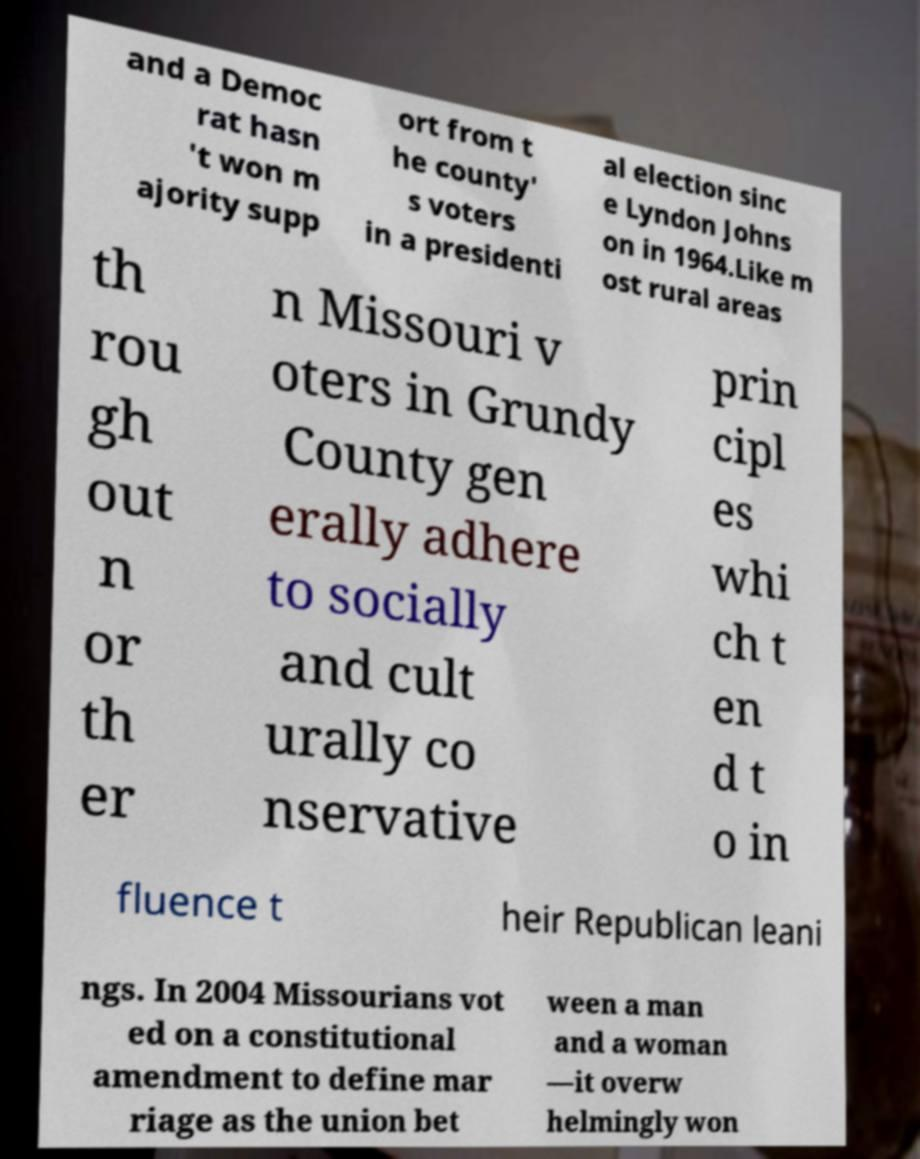Could you assist in decoding the text presented in this image and type it out clearly? and a Democ rat hasn 't won m ajority supp ort from t he county' s voters in a presidenti al election sinc e Lyndon Johns on in 1964.Like m ost rural areas th rou gh out n or th er n Missouri v oters in Grundy County gen erally adhere to socially and cult urally co nservative prin cipl es whi ch t en d t o in fluence t heir Republican leani ngs. In 2004 Missourians vot ed on a constitutional amendment to define mar riage as the union bet ween a man and a woman —it overw helmingly won 